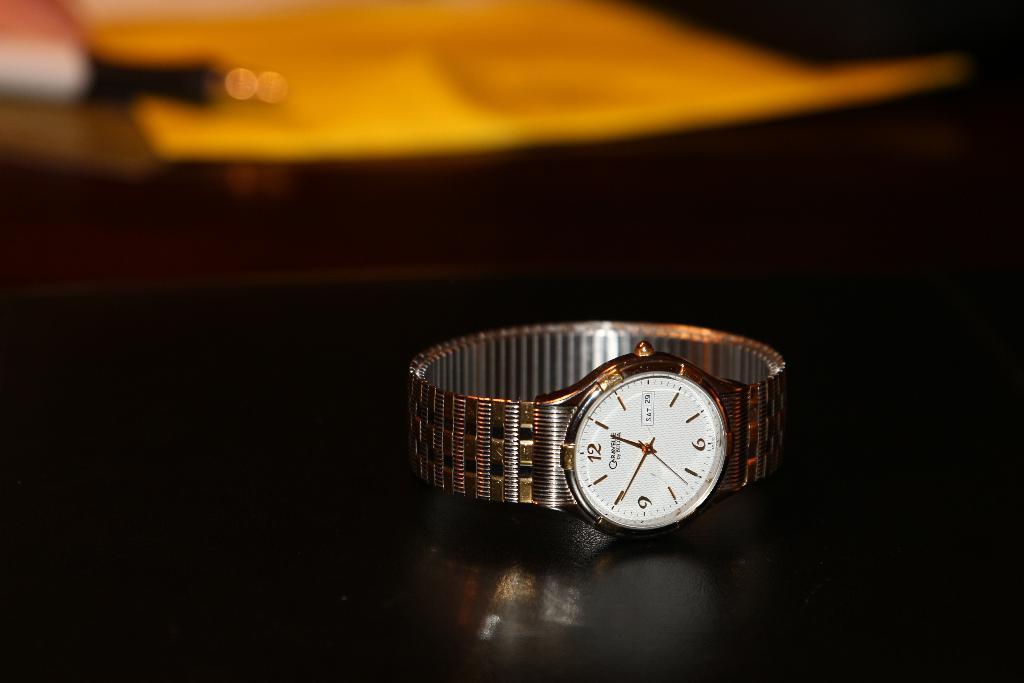What time is shown on watch?
Keep it short and to the point. 12:50. 